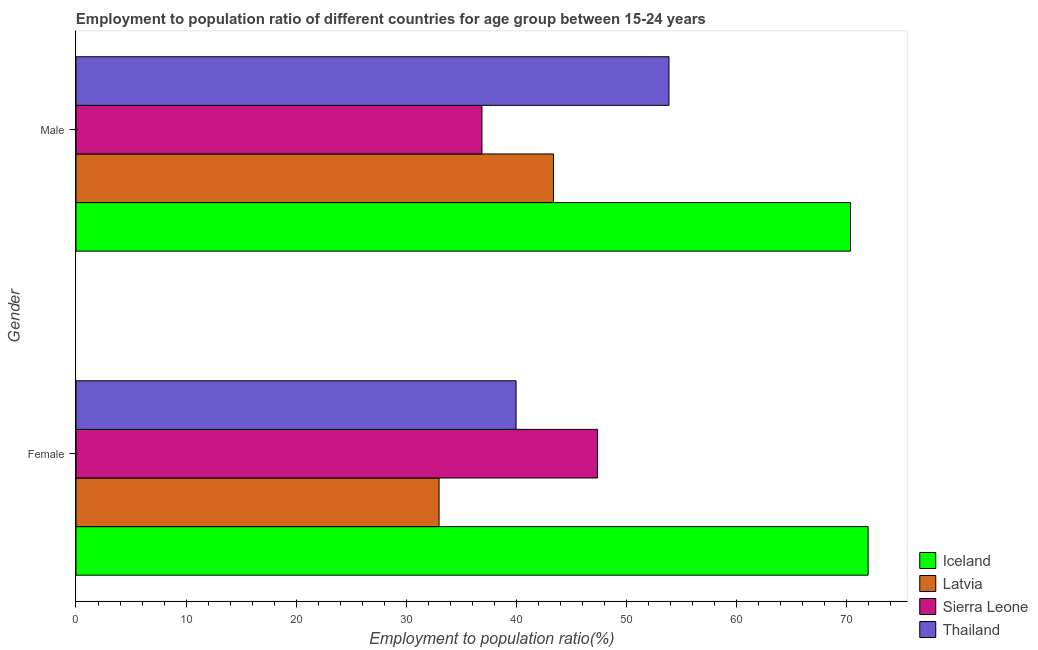How many groups of bars are there?
Provide a succinct answer. 2. How many bars are there on the 1st tick from the top?
Provide a succinct answer. 4. How many bars are there on the 1st tick from the bottom?
Provide a succinct answer. 4. What is the label of the 2nd group of bars from the top?
Give a very brief answer. Female. What is the employment to population ratio(male) in Sierra Leone?
Keep it short and to the point. 36.9. Across all countries, what is the maximum employment to population ratio(male)?
Your answer should be very brief. 70.4. In which country was the employment to population ratio(male) minimum?
Provide a short and direct response. Sierra Leone. What is the total employment to population ratio(female) in the graph?
Keep it short and to the point. 192.4. What is the difference between the employment to population ratio(male) in Iceland and the employment to population ratio(female) in Sierra Leone?
Provide a short and direct response. 23. What is the average employment to population ratio(female) per country?
Your answer should be very brief. 48.1. In how many countries, is the employment to population ratio(male) greater than 32 %?
Your answer should be compact. 4. What is the ratio of the employment to population ratio(female) in Thailand to that in Iceland?
Ensure brevity in your answer.  0.56. What does the 1st bar from the top in Female represents?
Your response must be concise. Thailand. What does the 2nd bar from the bottom in Male represents?
Give a very brief answer. Latvia. How many bars are there?
Provide a succinct answer. 8. Are all the bars in the graph horizontal?
Offer a very short reply. Yes. How many countries are there in the graph?
Ensure brevity in your answer.  4. Are the values on the major ticks of X-axis written in scientific E-notation?
Your answer should be very brief. No. Where does the legend appear in the graph?
Make the answer very short. Bottom right. How many legend labels are there?
Keep it short and to the point. 4. How are the legend labels stacked?
Your answer should be very brief. Vertical. What is the title of the graph?
Give a very brief answer. Employment to population ratio of different countries for age group between 15-24 years. Does "Caribbean small states" appear as one of the legend labels in the graph?
Provide a succinct answer. No. What is the label or title of the X-axis?
Make the answer very short. Employment to population ratio(%). What is the Employment to population ratio(%) of Iceland in Female?
Offer a terse response. 72. What is the Employment to population ratio(%) in Sierra Leone in Female?
Ensure brevity in your answer.  47.4. What is the Employment to population ratio(%) in Iceland in Male?
Provide a short and direct response. 70.4. What is the Employment to population ratio(%) in Latvia in Male?
Your response must be concise. 43.4. What is the Employment to population ratio(%) in Sierra Leone in Male?
Your answer should be very brief. 36.9. What is the Employment to population ratio(%) of Thailand in Male?
Your response must be concise. 53.9. Across all Gender, what is the maximum Employment to population ratio(%) of Iceland?
Offer a very short reply. 72. Across all Gender, what is the maximum Employment to population ratio(%) in Latvia?
Ensure brevity in your answer.  43.4. Across all Gender, what is the maximum Employment to population ratio(%) in Sierra Leone?
Provide a succinct answer. 47.4. Across all Gender, what is the maximum Employment to population ratio(%) in Thailand?
Offer a terse response. 53.9. Across all Gender, what is the minimum Employment to population ratio(%) of Iceland?
Offer a very short reply. 70.4. Across all Gender, what is the minimum Employment to population ratio(%) in Sierra Leone?
Keep it short and to the point. 36.9. Across all Gender, what is the minimum Employment to population ratio(%) in Thailand?
Offer a very short reply. 40. What is the total Employment to population ratio(%) of Iceland in the graph?
Your answer should be compact. 142.4. What is the total Employment to population ratio(%) in Latvia in the graph?
Your answer should be compact. 76.4. What is the total Employment to population ratio(%) in Sierra Leone in the graph?
Your answer should be very brief. 84.3. What is the total Employment to population ratio(%) in Thailand in the graph?
Offer a very short reply. 93.9. What is the difference between the Employment to population ratio(%) of Sierra Leone in Female and that in Male?
Provide a succinct answer. 10.5. What is the difference between the Employment to population ratio(%) of Thailand in Female and that in Male?
Your answer should be compact. -13.9. What is the difference between the Employment to population ratio(%) of Iceland in Female and the Employment to population ratio(%) of Latvia in Male?
Your response must be concise. 28.6. What is the difference between the Employment to population ratio(%) of Iceland in Female and the Employment to population ratio(%) of Sierra Leone in Male?
Provide a succinct answer. 35.1. What is the difference between the Employment to population ratio(%) of Iceland in Female and the Employment to population ratio(%) of Thailand in Male?
Your answer should be very brief. 18.1. What is the difference between the Employment to population ratio(%) of Latvia in Female and the Employment to population ratio(%) of Sierra Leone in Male?
Your answer should be very brief. -3.9. What is the difference between the Employment to population ratio(%) of Latvia in Female and the Employment to population ratio(%) of Thailand in Male?
Keep it short and to the point. -20.9. What is the average Employment to population ratio(%) of Iceland per Gender?
Ensure brevity in your answer.  71.2. What is the average Employment to population ratio(%) of Latvia per Gender?
Provide a short and direct response. 38.2. What is the average Employment to population ratio(%) in Sierra Leone per Gender?
Your answer should be compact. 42.15. What is the average Employment to population ratio(%) in Thailand per Gender?
Make the answer very short. 46.95. What is the difference between the Employment to population ratio(%) of Iceland and Employment to population ratio(%) of Sierra Leone in Female?
Your response must be concise. 24.6. What is the difference between the Employment to population ratio(%) of Iceland and Employment to population ratio(%) of Thailand in Female?
Your answer should be compact. 32. What is the difference between the Employment to population ratio(%) of Latvia and Employment to population ratio(%) of Sierra Leone in Female?
Offer a terse response. -14.4. What is the difference between the Employment to population ratio(%) of Sierra Leone and Employment to population ratio(%) of Thailand in Female?
Make the answer very short. 7.4. What is the difference between the Employment to population ratio(%) of Iceland and Employment to population ratio(%) of Latvia in Male?
Your answer should be very brief. 27. What is the difference between the Employment to population ratio(%) in Iceland and Employment to population ratio(%) in Sierra Leone in Male?
Ensure brevity in your answer.  33.5. What is the difference between the Employment to population ratio(%) in Iceland and Employment to population ratio(%) in Thailand in Male?
Your response must be concise. 16.5. What is the difference between the Employment to population ratio(%) of Latvia and Employment to population ratio(%) of Sierra Leone in Male?
Provide a short and direct response. 6.5. What is the difference between the Employment to population ratio(%) in Sierra Leone and Employment to population ratio(%) in Thailand in Male?
Your response must be concise. -17. What is the ratio of the Employment to population ratio(%) in Iceland in Female to that in Male?
Offer a terse response. 1.02. What is the ratio of the Employment to population ratio(%) in Latvia in Female to that in Male?
Ensure brevity in your answer.  0.76. What is the ratio of the Employment to population ratio(%) in Sierra Leone in Female to that in Male?
Offer a very short reply. 1.28. What is the ratio of the Employment to population ratio(%) in Thailand in Female to that in Male?
Your response must be concise. 0.74. What is the difference between the highest and the second highest Employment to population ratio(%) of Latvia?
Ensure brevity in your answer.  10.4. What is the difference between the highest and the second highest Employment to population ratio(%) in Thailand?
Your answer should be very brief. 13.9. What is the difference between the highest and the lowest Employment to population ratio(%) in Iceland?
Keep it short and to the point. 1.6. What is the difference between the highest and the lowest Employment to population ratio(%) in Latvia?
Keep it short and to the point. 10.4. What is the difference between the highest and the lowest Employment to population ratio(%) in Thailand?
Provide a short and direct response. 13.9. 